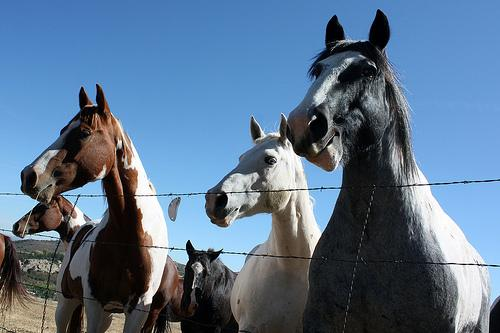Describe any patterns or unique features of the horses in the image. One horse is red and white, one has white around its eyes and down the center of its face, and another has a black mane. What role does the man play in the product advertisement task related to the image? The man holding the surfboards under his arm could represent an active lifestyle or outdoor sports, which may be emphasized in the advertisement. Identify the type of enclosure surrounding the horses and any additional details about it. The horses are enclosed by a barbed wire fence, which covers the entire image. Mention the total number of horses in the image and their positions in relation to one another. There are five horses, three standing near a fence, one in the middle, and one at the back. What is the most dominant color in the sky, and which task does this information belong to? The sky is a deep blue color, and it belongs to the visual entailment task. In the referential expression grounding task, what element corresponds to the provided expressions? The provided expressions refer to the surfboards and the man holding them as the main subjects in different positions. What are the main objects held in the man's arms, and where are they located on the image? The man is holding two surfboards under his arm, with multiple instances of their bounding boxes at various coordinates. Describe a possible multi-choice VQA question about the horses, and provide the correct answer. C) White horse Provide a brief reason for different visual entailing tasks regarding the image. Visual entailment tasks can test understanding of the image, identify colors, and recognize patterns or unique features of the subjects. List three colors present in the image and identify the objects they describe. Deep blue - sky, red and white - horse, black and white - another horse 